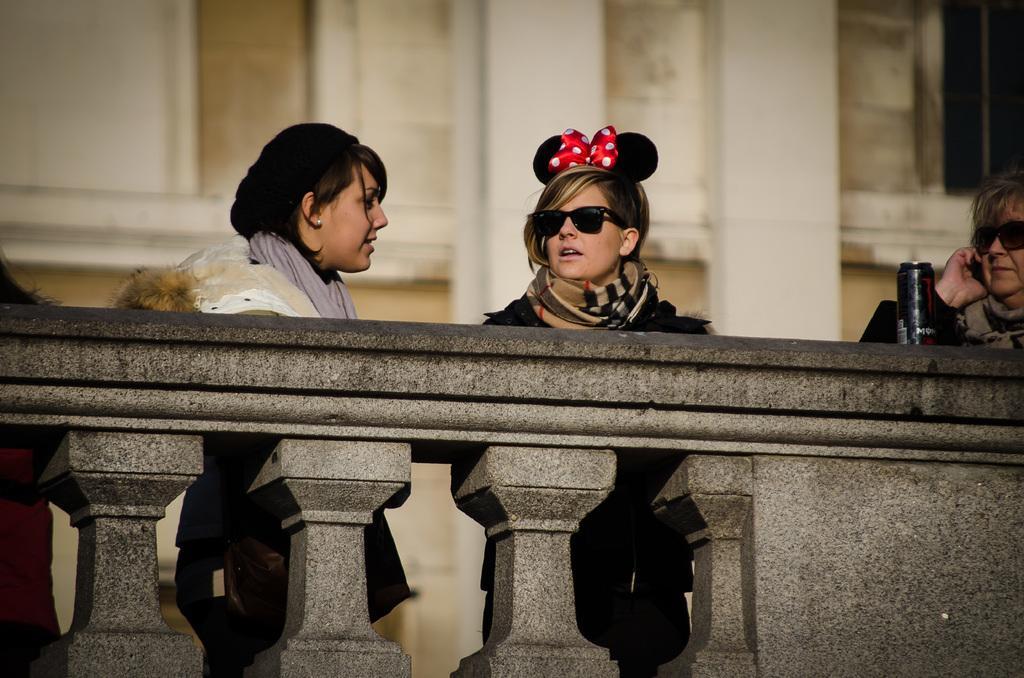In one or two sentences, can you explain what this image depicts? In this image we can see few people standing near the wall and there is a tin on the wall, in the background it looks like a building. 